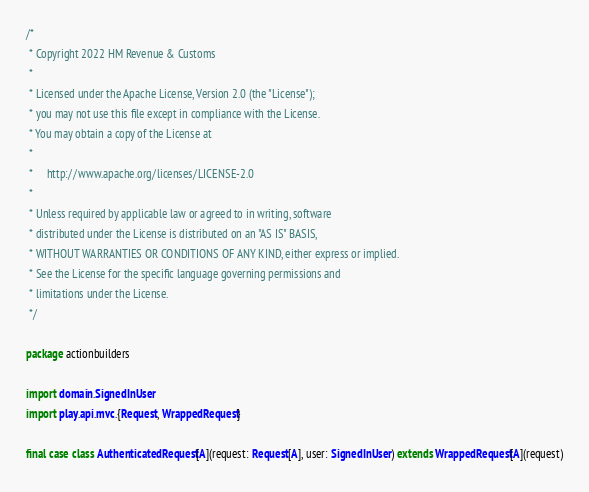<code> <loc_0><loc_0><loc_500><loc_500><_Scala_>/*
 * Copyright 2022 HM Revenue & Customs
 *
 * Licensed under the Apache License, Version 2.0 (the "License");
 * you may not use this file except in compliance with the License.
 * You may obtain a copy of the License at
 *
 *     http://www.apache.org/licenses/LICENSE-2.0
 *
 * Unless required by applicable law or agreed to in writing, software
 * distributed under the License is distributed on an "AS IS" BASIS,
 * WITHOUT WARRANTIES OR CONDITIONS OF ANY KIND, either express or implied.
 * See the License for the specific language governing permissions and
 * limitations under the License.
 */

package actionbuilders

import domain.SignedInUser
import play.api.mvc.{Request, WrappedRequest}

final case class AuthenticatedRequest[A](request: Request[A], user: SignedInUser) extends WrappedRequest[A](request)

</code> 